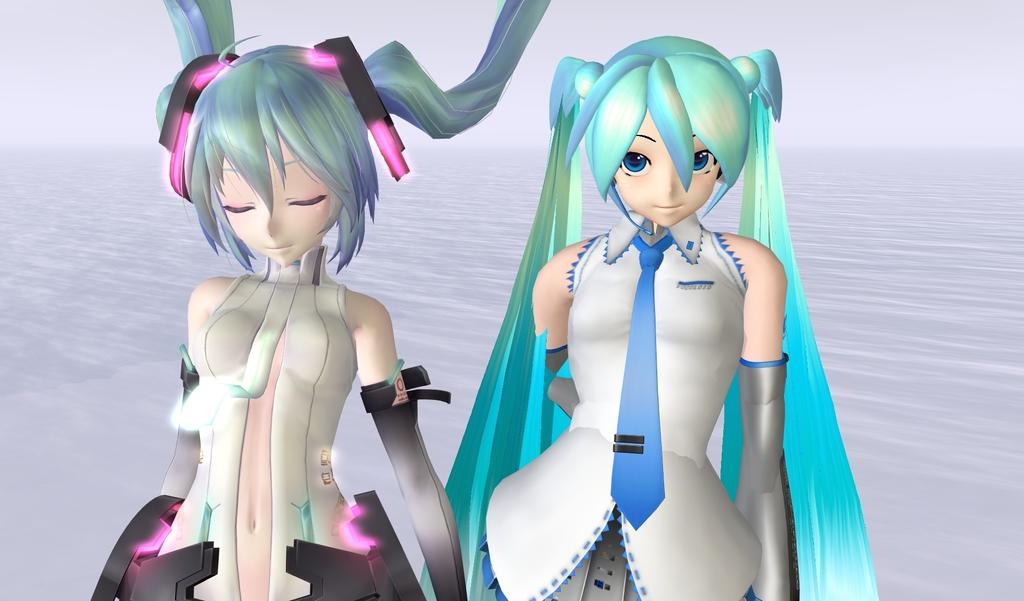Could you give a brief overview of what you see in this image? In the image there are two animated pictures of girls and behind the girls there is a white surface. 